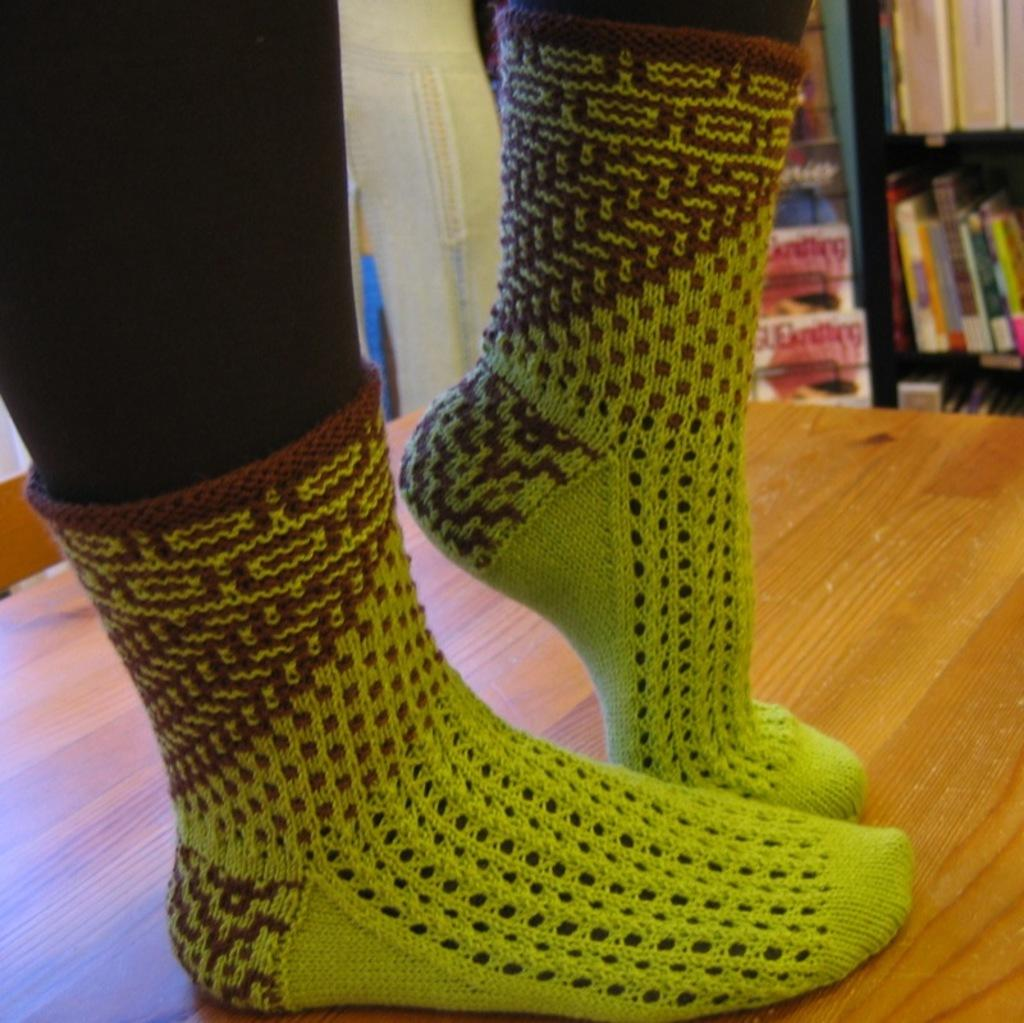What is the main subject of the image? There is a person in the image. What part of the person's body can be seen? The person's legs are visible. Where is the person located in the image? The person is standing on a table. What type of clothing is the person wearing on their feet? The person is wearing socks. What can be seen in the background of the image? There are books in the background of the image, on a rack. What type of expert advice can be heard from the person in the image? There is no indication in the image that the person is providing expert advice, as the image only shows the person standing on a table and wearing socks. 